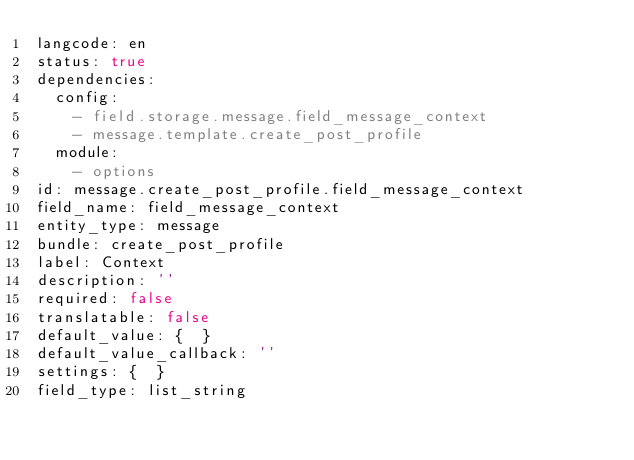<code> <loc_0><loc_0><loc_500><loc_500><_YAML_>langcode: en
status: true
dependencies:
  config:
    - field.storage.message.field_message_context
    - message.template.create_post_profile
  module:
    - options
id: message.create_post_profile.field_message_context
field_name: field_message_context
entity_type: message
bundle: create_post_profile
label: Context
description: ''
required: false
translatable: false
default_value: {  }
default_value_callback: ''
settings: {  }
field_type: list_string
</code> 